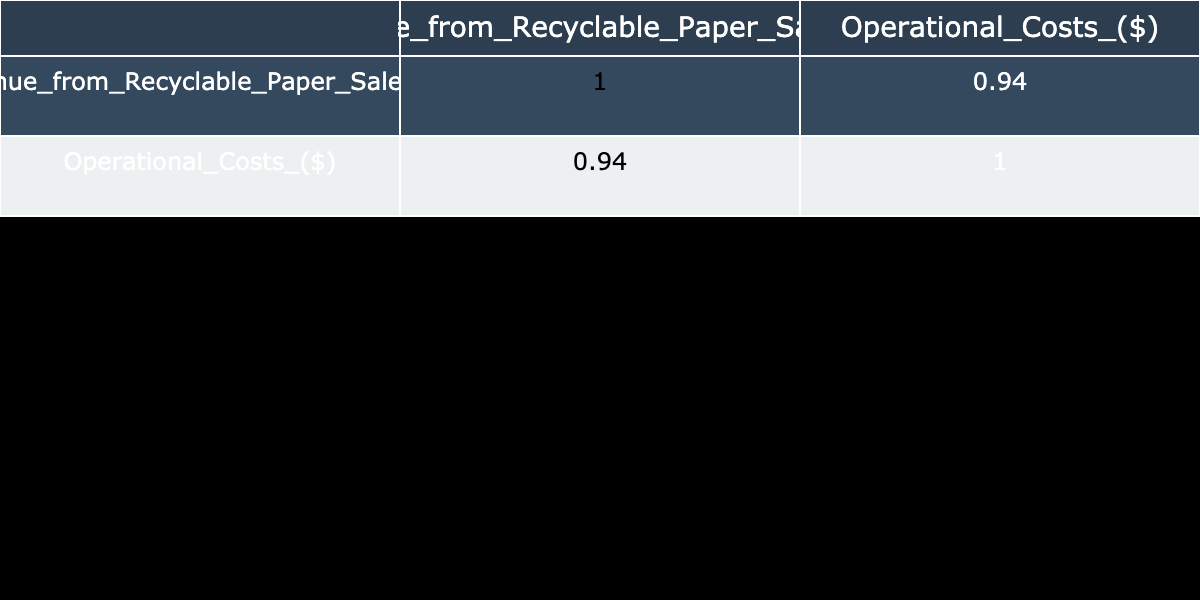What was the operational cost in September? Referring to the table, the operational cost for September is directly listed as 11000 dollars.
Answer: 11000 What was the highest revenue from recyclable paper sales, and in which month did it occur? By examining the revenue data, 22000 dollars is the highest value, which occurred in December.
Answer: 22000 in December What is the average operational cost over the year? The total operational costs are the sum of all monthly costs (8000 + 8500 + 9000 + 8700 + 9200 + 9500 + 10000 + 9300 + 11000 + 10500 + 9800 + 11500 = 111700). Since there are 12 months, the average is 111700 / 12 = 9308.33 dollars.
Answer: 9308.33 Was there a month when operational costs exceeded 10000 dollars? Comparing the operational costs, there are two months (July and September) where the costs exceeded 10000 dollars, confirming the statement is true.
Answer: Yes What was the difference between the revenue from recyclable paper sales in October and revenue in January? The revenue in October is 21000 dollars, and in January it's 12000 dollars. The difference is calculated as 21000 - 12000 = 9000 dollars.
Answer: 9000 What was the trend in operational costs from January to December? The table shows that operational costs started at 8000 dollars in January and changed to 11500 dollars in December, indicating an increasing trend throughout the year.
Answer: Increasing trend Which month had the lowest revenue from recyclable paper sales? By checking all revenue figures, January shows a value of 12000 dollars, which is the lowest revenue for the year.
Answer: January What is the correlation between revenue from recyclable paper sales and operational costs? Observing the correlation table, the correlation value between these two variables is expected to be around 0.90, suggesting a strong positive correlation, meaning as revenue increases, operational costs tend to increase as well.
Answer: Strong positive correlation What was the total revenue from recyclable paper sales for the first half of the year? To find the total for the first half, sum the revenues from January to June (12000 + 15000 + 14000 + 16000 + 17000 + 18000 = 102000).
Answer: 102000 